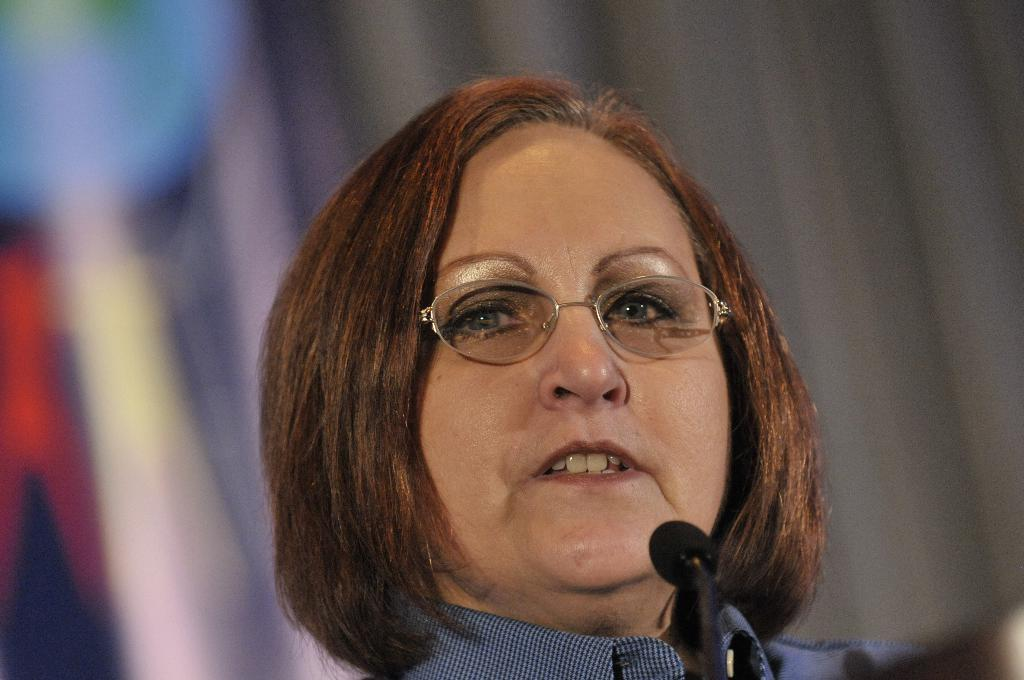Who is the main subject in the image? There is a woman in the image. What is the woman doing in the image? The woman is talking in the image. How is the woman communicating her message? The woman is using a mic in the image. What type of apple is the woman eating while talking in the image? There is no apple present in the image; the woman is using a mic to talk. 